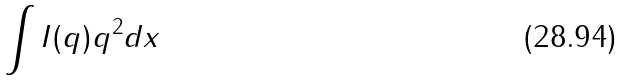<formula> <loc_0><loc_0><loc_500><loc_500>\int I ( q ) q ^ { 2 } d x</formula> 